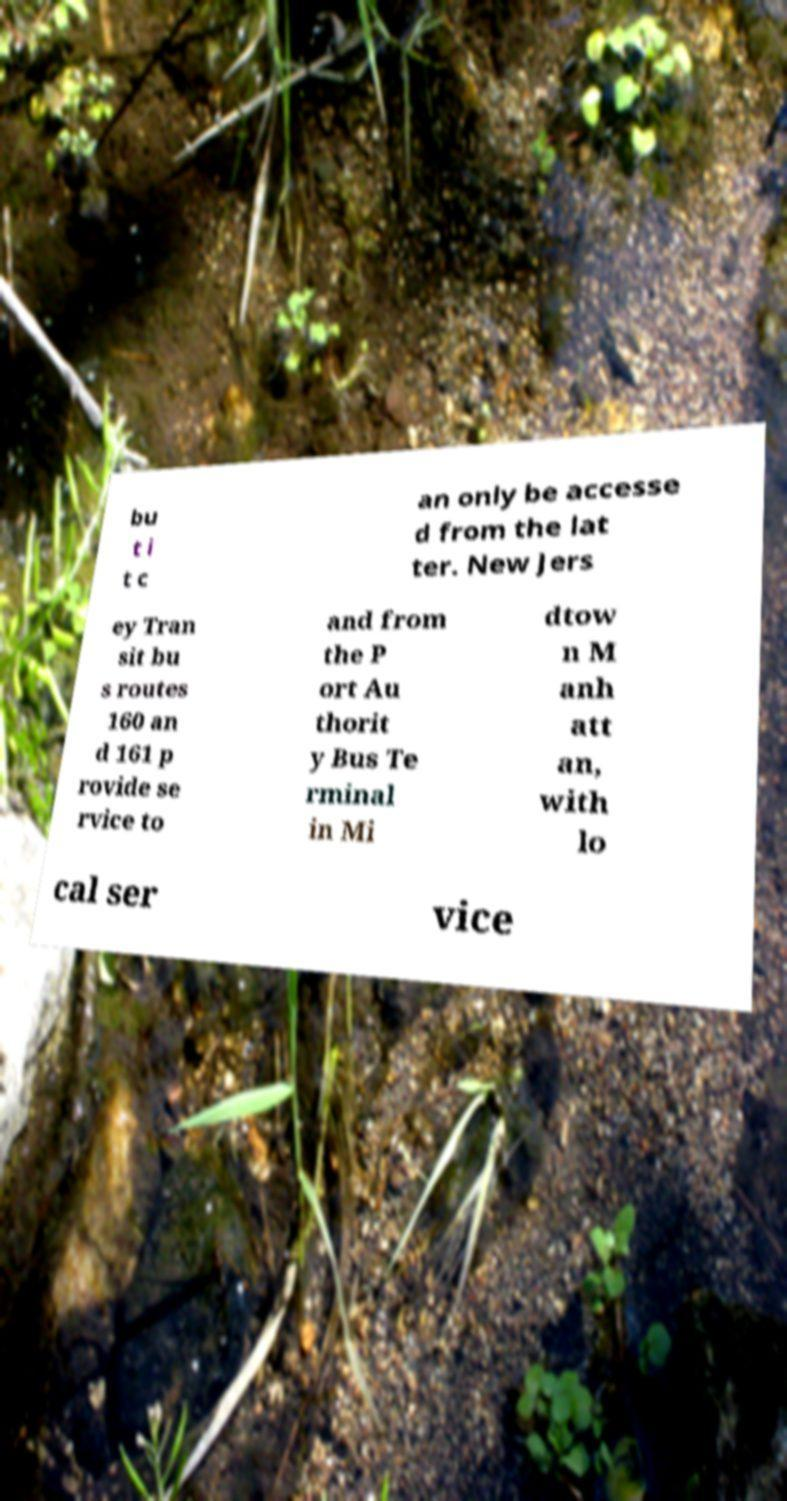Can you read and provide the text displayed in the image?This photo seems to have some interesting text. Can you extract and type it out for me? bu t i t c an only be accesse d from the lat ter. New Jers ey Tran sit bu s routes 160 an d 161 p rovide se rvice to and from the P ort Au thorit y Bus Te rminal in Mi dtow n M anh att an, with lo cal ser vice 